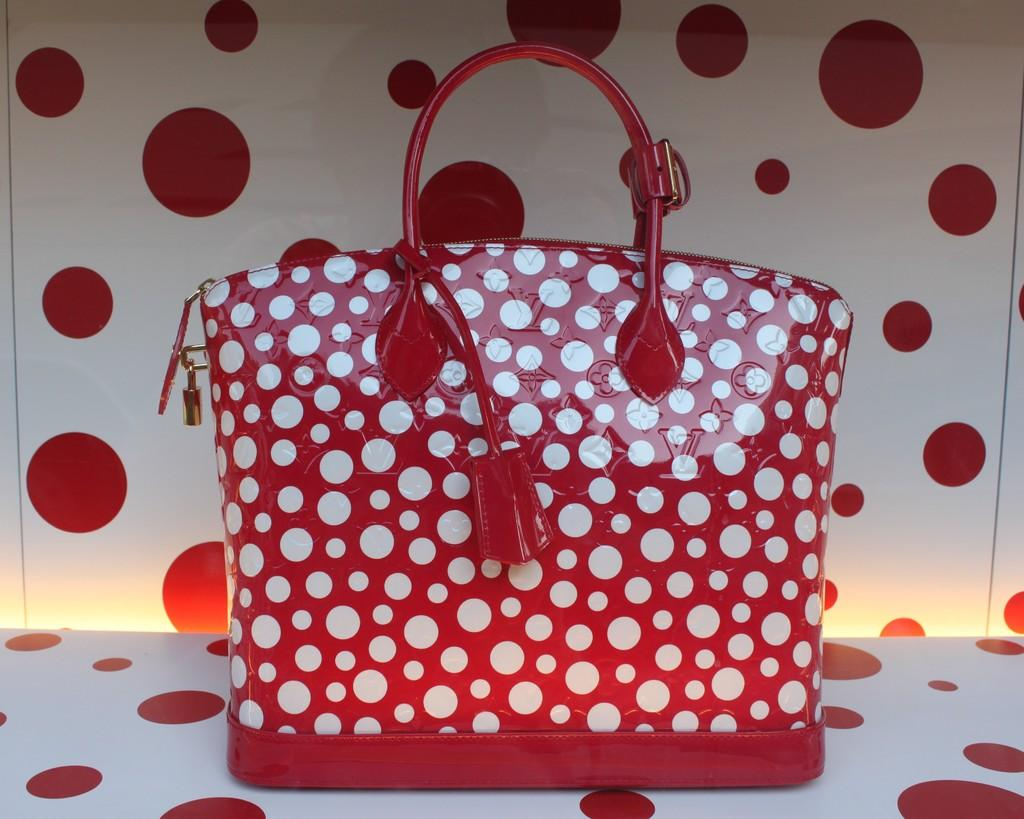What is the color and pattern of the handbag in the image? The handbag in the image is red and white with a dotted pattern. What is the handbag placed on in the image? The handbag is placed on a red and white board. Is there any security feature on the handbag? Yes, there is a lock on the handbag. How many crates are stacked next to the handbag in the image? There are no crates present in the image. What type of bomb is hidden inside the handbag in the image? There is no bomb present in the image; it is a handbag with a lock. 